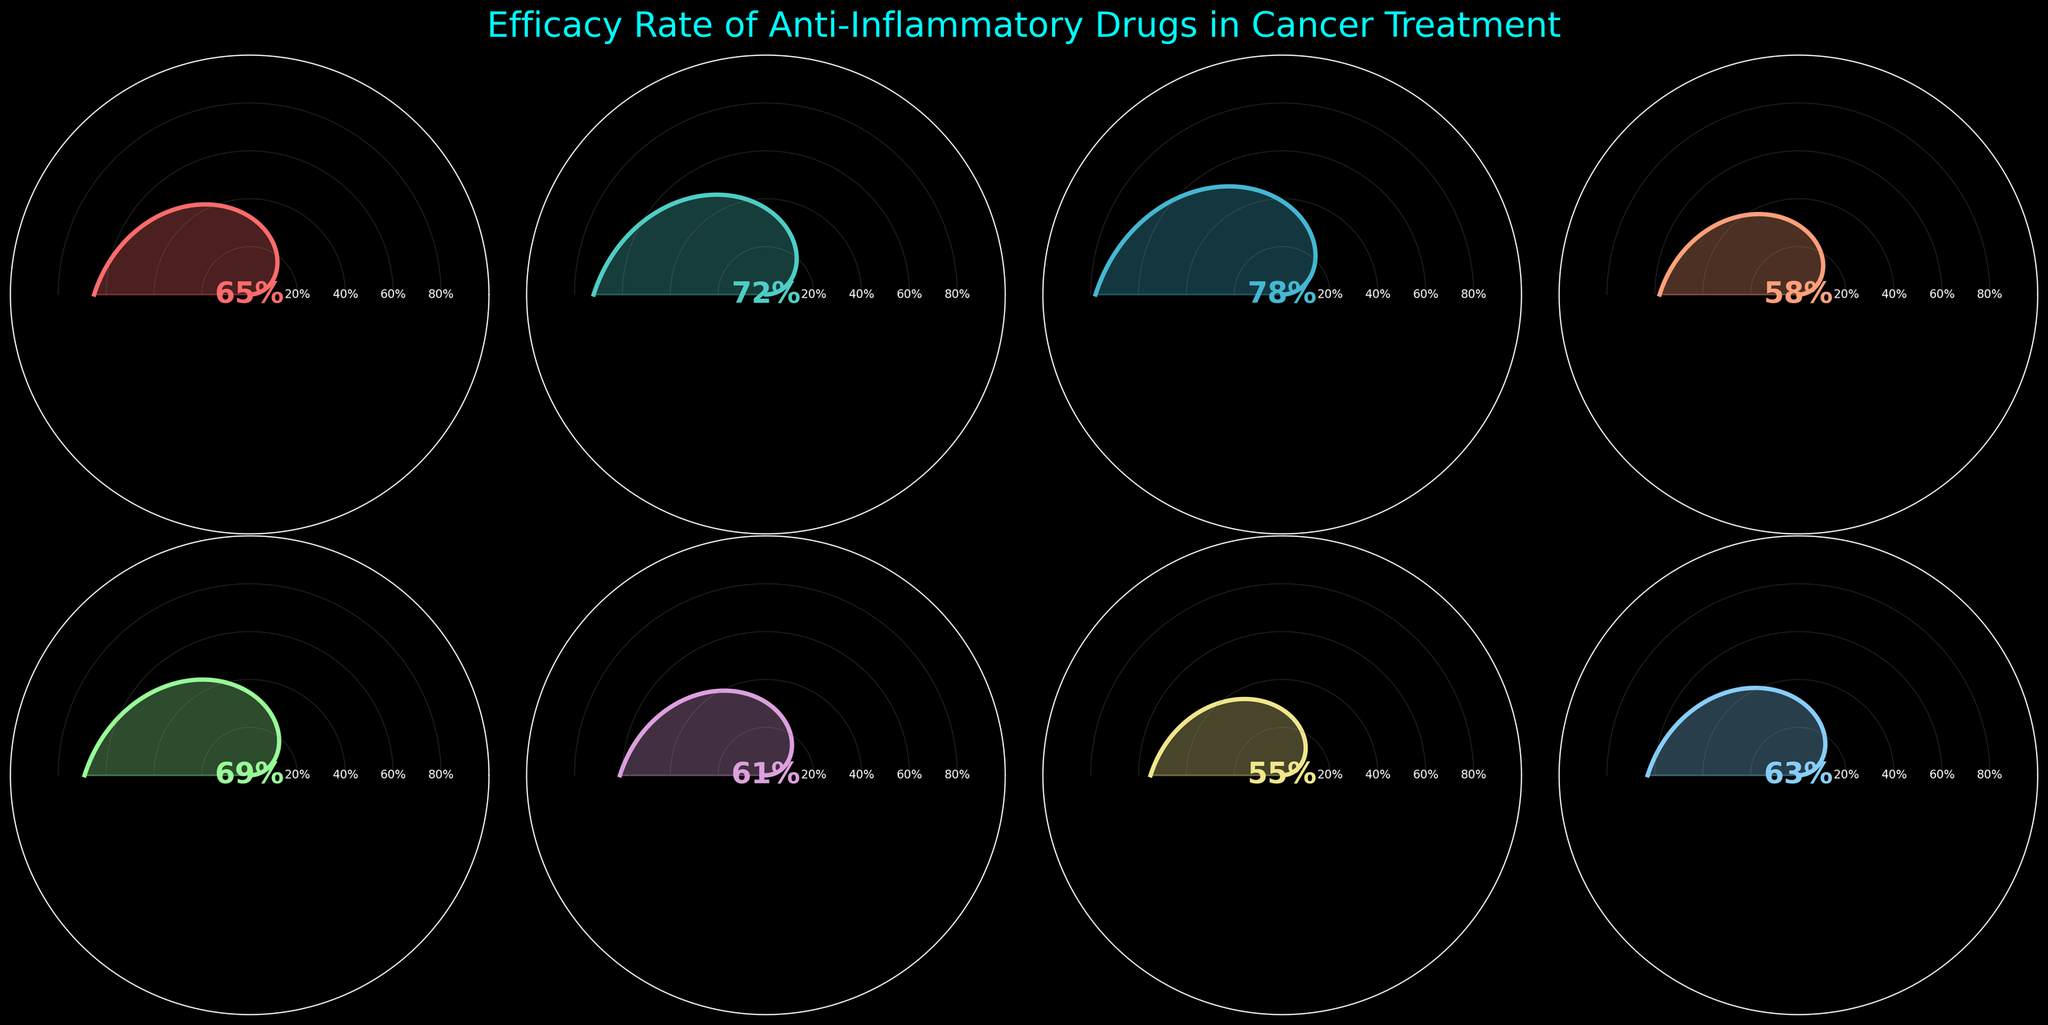What is the title of the figure? The title can be found at the top of the figure. It provides a brief description of the content of the chart.
Answer: Efficacy Rate of Anti-Inflammatory Drugs in Cancer Treatment Which drug has the highest efficacy rate? By checking the efficacy percentages displayed next to each gauge, the drug with the highest value can be identified.
Answer: Dexamethasone What is the average efficacy rate of all the drugs shown? Add all the efficacy rates and divide by the number of drugs: (65+72+78+58+69+61+55+63)/8 = 65.125
Answer: 65.125% Which drug has an efficacy rate lower than 60%? The gauge charts with less than 60% efficacy rate can be identified by checking the percentages shown for each drug.
Answer: Ibuprofen, Sulindac How many drugs have an efficacy rate above 70%? By counting the drugs whose efficacy rate is greater than 70, we can find the number.
Answer: 2 What is the difference in efficacy rate between Aspirin and Celecoxib? Calculate the difference by subtracting the efficacy rate of Aspirin from Celecoxib: 72 - 65 = 7
Answer: 7 Which drug has the closest efficacy rate to the median efficacy value? To find the median, first order the values: [55, 58, 61, 63, 65, 69, 72, 78]. The median is the average of the middle two values: (65+63)/2 = 64. The closest efficacy rate to 64 is Aspirin (65).
Answer: Aspirin How many drugs have an efficacy rate between 60% and 70%? Count the number of drugs whose efficacy rates fall within the range of 60% to 70%.
Answer: 4 Do any two drugs have the same efficacy rate? By examining the efficacy rates displayed next to each gauge, it is clear that no two drugs share the same rate.
Answer: No Which drug has the lowest efficacy rate? Identifying the drug with the smallest percentage shown next to its gauge identifies it.
Answer: Sulindac 